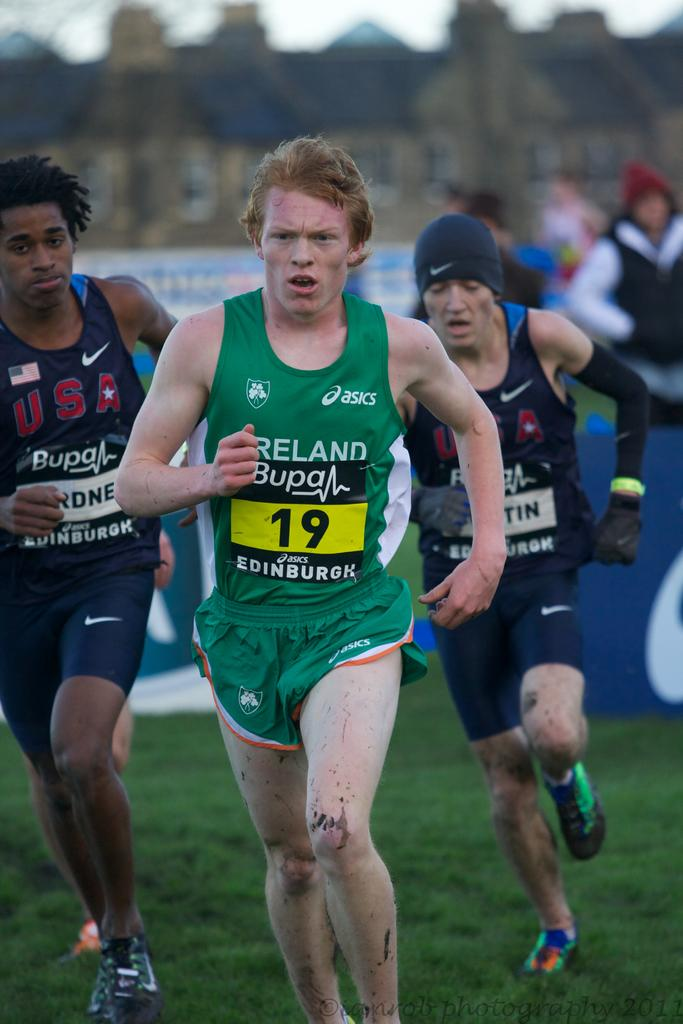<image>
Offer a succinct explanation of the picture presented. Men are running in a race and the one in green has number 19. 